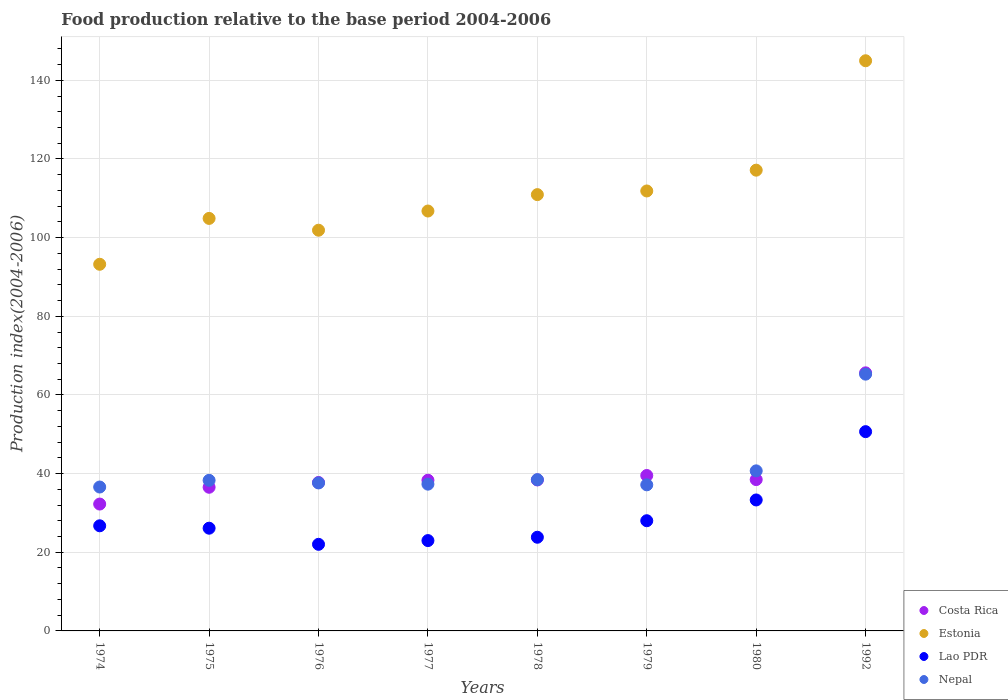What is the food production index in Costa Rica in 1980?
Offer a very short reply. 38.48. Across all years, what is the maximum food production index in Lao PDR?
Offer a terse response. 50.67. Across all years, what is the minimum food production index in Estonia?
Offer a terse response. 93.23. In which year was the food production index in Lao PDR minimum?
Offer a terse response. 1976. What is the total food production index in Nepal in the graph?
Make the answer very short. 331.43. What is the difference between the food production index in Nepal in 1980 and that in 1992?
Ensure brevity in your answer.  -24.59. What is the difference between the food production index in Estonia in 1992 and the food production index in Nepal in 1977?
Your answer should be compact. 107.66. What is the average food production index in Nepal per year?
Your answer should be very brief. 41.43. In the year 1980, what is the difference between the food production index in Costa Rica and food production index in Nepal?
Give a very brief answer. -2.22. What is the ratio of the food production index in Lao PDR in 1976 to that in 1979?
Your answer should be very brief. 0.79. Is the difference between the food production index in Costa Rica in 1976 and 1992 greater than the difference between the food production index in Nepal in 1976 and 1992?
Your response must be concise. No. What is the difference between the highest and the second highest food production index in Estonia?
Offer a very short reply. 27.82. What is the difference between the highest and the lowest food production index in Lao PDR?
Make the answer very short. 28.65. Is it the case that in every year, the sum of the food production index in Nepal and food production index in Lao PDR  is greater than the sum of food production index in Costa Rica and food production index in Estonia?
Your answer should be compact. No. What is the difference between two consecutive major ticks on the Y-axis?
Make the answer very short. 20. Does the graph contain any zero values?
Ensure brevity in your answer.  No. Does the graph contain grids?
Give a very brief answer. Yes. How are the legend labels stacked?
Offer a very short reply. Vertical. What is the title of the graph?
Offer a very short reply. Food production relative to the base period 2004-2006. What is the label or title of the Y-axis?
Offer a very short reply. Production index(2004-2006). What is the Production index(2004-2006) of Costa Rica in 1974?
Provide a succinct answer. 32.26. What is the Production index(2004-2006) of Estonia in 1974?
Your answer should be very brief. 93.23. What is the Production index(2004-2006) of Lao PDR in 1974?
Make the answer very short. 26.73. What is the Production index(2004-2006) of Nepal in 1974?
Your response must be concise. 36.59. What is the Production index(2004-2006) of Costa Rica in 1975?
Your response must be concise. 36.53. What is the Production index(2004-2006) of Estonia in 1975?
Offer a very short reply. 104.89. What is the Production index(2004-2006) of Lao PDR in 1975?
Ensure brevity in your answer.  26.12. What is the Production index(2004-2006) in Nepal in 1975?
Your answer should be compact. 38.29. What is the Production index(2004-2006) in Costa Rica in 1976?
Give a very brief answer. 37.74. What is the Production index(2004-2006) in Estonia in 1976?
Provide a short and direct response. 101.89. What is the Production index(2004-2006) in Lao PDR in 1976?
Your answer should be compact. 22.02. What is the Production index(2004-2006) of Nepal in 1976?
Ensure brevity in your answer.  37.63. What is the Production index(2004-2006) of Costa Rica in 1977?
Ensure brevity in your answer.  38.32. What is the Production index(2004-2006) of Estonia in 1977?
Your answer should be compact. 106.77. What is the Production index(2004-2006) of Lao PDR in 1977?
Make the answer very short. 22.97. What is the Production index(2004-2006) of Nepal in 1977?
Offer a terse response. 37.32. What is the Production index(2004-2006) in Costa Rica in 1978?
Offer a terse response. 38.39. What is the Production index(2004-2006) of Estonia in 1978?
Provide a short and direct response. 110.94. What is the Production index(2004-2006) in Lao PDR in 1978?
Offer a terse response. 23.82. What is the Production index(2004-2006) of Nepal in 1978?
Your response must be concise. 38.46. What is the Production index(2004-2006) in Costa Rica in 1979?
Provide a succinct answer. 39.52. What is the Production index(2004-2006) of Estonia in 1979?
Offer a very short reply. 111.87. What is the Production index(2004-2006) of Lao PDR in 1979?
Make the answer very short. 28.02. What is the Production index(2004-2006) in Nepal in 1979?
Your answer should be very brief. 37.15. What is the Production index(2004-2006) of Costa Rica in 1980?
Make the answer very short. 38.48. What is the Production index(2004-2006) in Estonia in 1980?
Keep it short and to the point. 117.16. What is the Production index(2004-2006) in Lao PDR in 1980?
Give a very brief answer. 33.3. What is the Production index(2004-2006) of Nepal in 1980?
Offer a very short reply. 40.7. What is the Production index(2004-2006) of Costa Rica in 1992?
Provide a succinct answer. 65.62. What is the Production index(2004-2006) in Estonia in 1992?
Give a very brief answer. 144.98. What is the Production index(2004-2006) of Lao PDR in 1992?
Give a very brief answer. 50.67. What is the Production index(2004-2006) of Nepal in 1992?
Provide a succinct answer. 65.29. Across all years, what is the maximum Production index(2004-2006) in Costa Rica?
Provide a short and direct response. 65.62. Across all years, what is the maximum Production index(2004-2006) in Estonia?
Provide a short and direct response. 144.98. Across all years, what is the maximum Production index(2004-2006) of Lao PDR?
Provide a succinct answer. 50.67. Across all years, what is the maximum Production index(2004-2006) of Nepal?
Give a very brief answer. 65.29. Across all years, what is the minimum Production index(2004-2006) in Costa Rica?
Your answer should be very brief. 32.26. Across all years, what is the minimum Production index(2004-2006) in Estonia?
Your answer should be very brief. 93.23. Across all years, what is the minimum Production index(2004-2006) of Lao PDR?
Offer a very short reply. 22.02. Across all years, what is the minimum Production index(2004-2006) of Nepal?
Make the answer very short. 36.59. What is the total Production index(2004-2006) of Costa Rica in the graph?
Your answer should be very brief. 326.86. What is the total Production index(2004-2006) of Estonia in the graph?
Provide a short and direct response. 891.73. What is the total Production index(2004-2006) in Lao PDR in the graph?
Provide a short and direct response. 233.65. What is the total Production index(2004-2006) in Nepal in the graph?
Provide a short and direct response. 331.43. What is the difference between the Production index(2004-2006) in Costa Rica in 1974 and that in 1975?
Offer a very short reply. -4.27. What is the difference between the Production index(2004-2006) in Estonia in 1974 and that in 1975?
Your answer should be very brief. -11.66. What is the difference between the Production index(2004-2006) of Lao PDR in 1974 and that in 1975?
Make the answer very short. 0.61. What is the difference between the Production index(2004-2006) in Nepal in 1974 and that in 1975?
Offer a very short reply. -1.7. What is the difference between the Production index(2004-2006) in Costa Rica in 1974 and that in 1976?
Offer a terse response. -5.48. What is the difference between the Production index(2004-2006) of Estonia in 1974 and that in 1976?
Ensure brevity in your answer.  -8.66. What is the difference between the Production index(2004-2006) in Lao PDR in 1974 and that in 1976?
Offer a terse response. 4.71. What is the difference between the Production index(2004-2006) in Nepal in 1974 and that in 1976?
Give a very brief answer. -1.04. What is the difference between the Production index(2004-2006) in Costa Rica in 1974 and that in 1977?
Your response must be concise. -6.06. What is the difference between the Production index(2004-2006) in Estonia in 1974 and that in 1977?
Offer a very short reply. -13.54. What is the difference between the Production index(2004-2006) in Lao PDR in 1974 and that in 1977?
Your answer should be very brief. 3.76. What is the difference between the Production index(2004-2006) in Nepal in 1974 and that in 1977?
Provide a succinct answer. -0.73. What is the difference between the Production index(2004-2006) of Costa Rica in 1974 and that in 1978?
Your response must be concise. -6.13. What is the difference between the Production index(2004-2006) of Estonia in 1974 and that in 1978?
Your response must be concise. -17.71. What is the difference between the Production index(2004-2006) of Lao PDR in 1974 and that in 1978?
Provide a short and direct response. 2.91. What is the difference between the Production index(2004-2006) in Nepal in 1974 and that in 1978?
Provide a succinct answer. -1.87. What is the difference between the Production index(2004-2006) in Costa Rica in 1974 and that in 1979?
Your answer should be very brief. -7.26. What is the difference between the Production index(2004-2006) of Estonia in 1974 and that in 1979?
Offer a very short reply. -18.64. What is the difference between the Production index(2004-2006) in Lao PDR in 1974 and that in 1979?
Provide a succinct answer. -1.29. What is the difference between the Production index(2004-2006) in Nepal in 1974 and that in 1979?
Make the answer very short. -0.56. What is the difference between the Production index(2004-2006) of Costa Rica in 1974 and that in 1980?
Make the answer very short. -6.22. What is the difference between the Production index(2004-2006) of Estonia in 1974 and that in 1980?
Provide a succinct answer. -23.93. What is the difference between the Production index(2004-2006) in Lao PDR in 1974 and that in 1980?
Your answer should be compact. -6.57. What is the difference between the Production index(2004-2006) in Nepal in 1974 and that in 1980?
Provide a short and direct response. -4.11. What is the difference between the Production index(2004-2006) in Costa Rica in 1974 and that in 1992?
Your response must be concise. -33.36. What is the difference between the Production index(2004-2006) in Estonia in 1974 and that in 1992?
Provide a succinct answer. -51.75. What is the difference between the Production index(2004-2006) of Lao PDR in 1974 and that in 1992?
Provide a succinct answer. -23.94. What is the difference between the Production index(2004-2006) of Nepal in 1974 and that in 1992?
Your answer should be compact. -28.7. What is the difference between the Production index(2004-2006) in Costa Rica in 1975 and that in 1976?
Make the answer very short. -1.21. What is the difference between the Production index(2004-2006) of Nepal in 1975 and that in 1976?
Ensure brevity in your answer.  0.66. What is the difference between the Production index(2004-2006) in Costa Rica in 1975 and that in 1977?
Offer a terse response. -1.79. What is the difference between the Production index(2004-2006) in Estonia in 1975 and that in 1977?
Make the answer very short. -1.88. What is the difference between the Production index(2004-2006) in Lao PDR in 1975 and that in 1977?
Keep it short and to the point. 3.15. What is the difference between the Production index(2004-2006) in Nepal in 1975 and that in 1977?
Offer a terse response. 0.97. What is the difference between the Production index(2004-2006) in Costa Rica in 1975 and that in 1978?
Ensure brevity in your answer.  -1.86. What is the difference between the Production index(2004-2006) of Estonia in 1975 and that in 1978?
Your response must be concise. -6.05. What is the difference between the Production index(2004-2006) of Nepal in 1975 and that in 1978?
Your response must be concise. -0.17. What is the difference between the Production index(2004-2006) in Costa Rica in 1975 and that in 1979?
Offer a very short reply. -2.99. What is the difference between the Production index(2004-2006) of Estonia in 1975 and that in 1979?
Make the answer very short. -6.98. What is the difference between the Production index(2004-2006) of Nepal in 1975 and that in 1979?
Offer a terse response. 1.14. What is the difference between the Production index(2004-2006) of Costa Rica in 1975 and that in 1980?
Offer a terse response. -1.95. What is the difference between the Production index(2004-2006) in Estonia in 1975 and that in 1980?
Your answer should be compact. -12.27. What is the difference between the Production index(2004-2006) of Lao PDR in 1975 and that in 1980?
Your response must be concise. -7.18. What is the difference between the Production index(2004-2006) in Nepal in 1975 and that in 1980?
Keep it short and to the point. -2.41. What is the difference between the Production index(2004-2006) of Costa Rica in 1975 and that in 1992?
Provide a succinct answer. -29.09. What is the difference between the Production index(2004-2006) in Estonia in 1975 and that in 1992?
Provide a succinct answer. -40.09. What is the difference between the Production index(2004-2006) of Lao PDR in 1975 and that in 1992?
Give a very brief answer. -24.55. What is the difference between the Production index(2004-2006) of Nepal in 1975 and that in 1992?
Keep it short and to the point. -27. What is the difference between the Production index(2004-2006) in Costa Rica in 1976 and that in 1977?
Provide a short and direct response. -0.58. What is the difference between the Production index(2004-2006) in Estonia in 1976 and that in 1977?
Offer a very short reply. -4.88. What is the difference between the Production index(2004-2006) in Lao PDR in 1976 and that in 1977?
Give a very brief answer. -0.95. What is the difference between the Production index(2004-2006) in Nepal in 1976 and that in 1977?
Provide a succinct answer. 0.31. What is the difference between the Production index(2004-2006) of Costa Rica in 1976 and that in 1978?
Provide a short and direct response. -0.65. What is the difference between the Production index(2004-2006) of Estonia in 1976 and that in 1978?
Offer a very short reply. -9.05. What is the difference between the Production index(2004-2006) of Nepal in 1976 and that in 1978?
Ensure brevity in your answer.  -0.83. What is the difference between the Production index(2004-2006) of Costa Rica in 1976 and that in 1979?
Provide a short and direct response. -1.78. What is the difference between the Production index(2004-2006) in Estonia in 1976 and that in 1979?
Provide a succinct answer. -9.98. What is the difference between the Production index(2004-2006) of Lao PDR in 1976 and that in 1979?
Give a very brief answer. -6. What is the difference between the Production index(2004-2006) in Nepal in 1976 and that in 1979?
Offer a terse response. 0.48. What is the difference between the Production index(2004-2006) of Costa Rica in 1976 and that in 1980?
Make the answer very short. -0.74. What is the difference between the Production index(2004-2006) in Estonia in 1976 and that in 1980?
Keep it short and to the point. -15.27. What is the difference between the Production index(2004-2006) of Lao PDR in 1976 and that in 1980?
Offer a terse response. -11.28. What is the difference between the Production index(2004-2006) of Nepal in 1976 and that in 1980?
Provide a short and direct response. -3.07. What is the difference between the Production index(2004-2006) in Costa Rica in 1976 and that in 1992?
Keep it short and to the point. -27.88. What is the difference between the Production index(2004-2006) in Estonia in 1976 and that in 1992?
Your answer should be very brief. -43.09. What is the difference between the Production index(2004-2006) of Lao PDR in 1976 and that in 1992?
Keep it short and to the point. -28.65. What is the difference between the Production index(2004-2006) in Nepal in 1976 and that in 1992?
Ensure brevity in your answer.  -27.66. What is the difference between the Production index(2004-2006) of Costa Rica in 1977 and that in 1978?
Give a very brief answer. -0.07. What is the difference between the Production index(2004-2006) of Estonia in 1977 and that in 1978?
Ensure brevity in your answer.  -4.17. What is the difference between the Production index(2004-2006) of Lao PDR in 1977 and that in 1978?
Give a very brief answer. -0.85. What is the difference between the Production index(2004-2006) in Nepal in 1977 and that in 1978?
Offer a very short reply. -1.14. What is the difference between the Production index(2004-2006) in Lao PDR in 1977 and that in 1979?
Your answer should be very brief. -5.05. What is the difference between the Production index(2004-2006) of Nepal in 1977 and that in 1979?
Offer a terse response. 0.17. What is the difference between the Production index(2004-2006) in Costa Rica in 1977 and that in 1980?
Ensure brevity in your answer.  -0.16. What is the difference between the Production index(2004-2006) in Estonia in 1977 and that in 1980?
Offer a very short reply. -10.39. What is the difference between the Production index(2004-2006) in Lao PDR in 1977 and that in 1980?
Your answer should be very brief. -10.33. What is the difference between the Production index(2004-2006) of Nepal in 1977 and that in 1980?
Provide a short and direct response. -3.38. What is the difference between the Production index(2004-2006) in Costa Rica in 1977 and that in 1992?
Offer a terse response. -27.3. What is the difference between the Production index(2004-2006) in Estonia in 1977 and that in 1992?
Ensure brevity in your answer.  -38.21. What is the difference between the Production index(2004-2006) in Lao PDR in 1977 and that in 1992?
Give a very brief answer. -27.7. What is the difference between the Production index(2004-2006) of Nepal in 1977 and that in 1992?
Ensure brevity in your answer.  -27.97. What is the difference between the Production index(2004-2006) of Costa Rica in 1978 and that in 1979?
Keep it short and to the point. -1.13. What is the difference between the Production index(2004-2006) of Estonia in 1978 and that in 1979?
Provide a short and direct response. -0.93. What is the difference between the Production index(2004-2006) of Lao PDR in 1978 and that in 1979?
Your answer should be compact. -4.2. What is the difference between the Production index(2004-2006) in Nepal in 1978 and that in 1979?
Provide a short and direct response. 1.31. What is the difference between the Production index(2004-2006) in Costa Rica in 1978 and that in 1980?
Make the answer very short. -0.09. What is the difference between the Production index(2004-2006) in Estonia in 1978 and that in 1980?
Your answer should be very brief. -6.22. What is the difference between the Production index(2004-2006) of Lao PDR in 1978 and that in 1980?
Offer a very short reply. -9.48. What is the difference between the Production index(2004-2006) in Nepal in 1978 and that in 1980?
Offer a very short reply. -2.24. What is the difference between the Production index(2004-2006) of Costa Rica in 1978 and that in 1992?
Provide a succinct answer. -27.23. What is the difference between the Production index(2004-2006) of Estonia in 1978 and that in 1992?
Give a very brief answer. -34.04. What is the difference between the Production index(2004-2006) in Lao PDR in 1978 and that in 1992?
Provide a succinct answer. -26.85. What is the difference between the Production index(2004-2006) in Nepal in 1978 and that in 1992?
Your answer should be very brief. -26.83. What is the difference between the Production index(2004-2006) in Estonia in 1979 and that in 1980?
Keep it short and to the point. -5.29. What is the difference between the Production index(2004-2006) of Lao PDR in 1979 and that in 1980?
Ensure brevity in your answer.  -5.28. What is the difference between the Production index(2004-2006) in Nepal in 1979 and that in 1980?
Give a very brief answer. -3.55. What is the difference between the Production index(2004-2006) of Costa Rica in 1979 and that in 1992?
Offer a very short reply. -26.1. What is the difference between the Production index(2004-2006) in Estonia in 1979 and that in 1992?
Offer a very short reply. -33.11. What is the difference between the Production index(2004-2006) of Lao PDR in 1979 and that in 1992?
Offer a terse response. -22.65. What is the difference between the Production index(2004-2006) of Nepal in 1979 and that in 1992?
Your answer should be compact. -28.14. What is the difference between the Production index(2004-2006) of Costa Rica in 1980 and that in 1992?
Your answer should be very brief. -27.14. What is the difference between the Production index(2004-2006) of Estonia in 1980 and that in 1992?
Your answer should be compact. -27.82. What is the difference between the Production index(2004-2006) in Lao PDR in 1980 and that in 1992?
Your response must be concise. -17.37. What is the difference between the Production index(2004-2006) in Nepal in 1980 and that in 1992?
Ensure brevity in your answer.  -24.59. What is the difference between the Production index(2004-2006) in Costa Rica in 1974 and the Production index(2004-2006) in Estonia in 1975?
Ensure brevity in your answer.  -72.63. What is the difference between the Production index(2004-2006) in Costa Rica in 1974 and the Production index(2004-2006) in Lao PDR in 1975?
Your response must be concise. 6.14. What is the difference between the Production index(2004-2006) of Costa Rica in 1974 and the Production index(2004-2006) of Nepal in 1975?
Your answer should be very brief. -6.03. What is the difference between the Production index(2004-2006) of Estonia in 1974 and the Production index(2004-2006) of Lao PDR in 1975?
Ensure brevity in your answer.  67.11. What is the difference between the Production index(2004-2006) of Estonia in 1974 and the Production index(2004-2006) of Nepal in 1975?
Your answer should be very brief. 54.94. What is the difference between the Production index(2004-2006) of Lao PDR in 1974 and the Production index(2004-2006) of Nepal in 1975?
Give a very brief answer. -11.56. What is the difference between the Production index(2004-2006) of Costa Rica in 1974 and the Production index(2004-2006) of Estonia in 1976?
Make the answer very short. -69.63. What is the difference between the Production index(2004-2006) in Costa Rica in 1974 and the Production index(2004-2006) in Lao PDR in 1976?
Provide a short and direct response. 10.24. What is the difference between the Production index(2004-2006) in Costa Rica in 1974 and the Production index(2004-2006) in Nepal in 1976?
Give a very brief answer. -5.37. What is the difference between the Production index(2004-2006) of Estonia in 1974 and the Production index(2004-2006) of Lao PDR in 1976?
Offer a terse response. 71.21. What is the difference between the Production index(2004-2006) in Estonia in 1974 and the Production index(2004-2006) in Nepal in 1976?
Your response must be concise. 55.6. What is the difference between the Production index(2004-2006) in Lao PDR in 1974 and the Production index(2004-2006) in Nepal in 1976?
Give a very brief answer. -10.9. What is the difference between the Production index(2004-2006) in Costa Rica in 1974 and the Production index(2004-2006) in Estonia in 1977?
Provide a succinct answer. -74.51. What is the difference between the Production index(2004-2006) of Costa Rica in 1974 and the Production index(2004-2006) of Lao PDR in 1977?
Ensure brevity in your answer.  9.29. What is the difference between the Production index(2004-2006) of Costa Rica in 1974 and the Production index(2004-2006) of Nepal in 1977?
Offer a terse response. -5.06. What is the difference between the Production index(2004-2006) of Estonia in 1974 and the Production index(2004-2006) of Lao PDR in 1977?
Your response must be concise. 70.26. What is the difference between the Production index(2004-2006) of Estonia in 1974 and the Production index(2004-2006) of Nepal in 1977?
Offer a very short reply. 55.91. What is the difference between the Production index(2004-2006) of Lao PDR in 1974 and the Production index(2004-2006) of Nepal in 1977?
Offer a terse response. -10.59. What is the difference between the Production index(2004-2006) in Costa Rica in 1974 and the Production index(2004-2006) in Estonia in 1978?
Ensure brevity in your answer.  -78.68. What is the difference between the Production index(2004-2006) of Costa Rica in 1974 and the Production index(2004-2006) of Lao PDR in 1978?
Offer a very short reply. 8.44. What is the difference between the Production index(2004-2006) in Costa Rica in 1974 and the Production index(2004-2006) in Nepal in 1978?
Your answer should be compact. -6.2. What is the difference between the Production index(2004-2006) in Estonia in 1974 and the Production index(2004-2006) in Lao PDR in 1978?
Provide a succinct answer. 69.41. What is the difference between the Production index(2004-2006) in Estonia in 1974 and the Production index(2004-2006) in Nepal in 1978?
Provide a short and direct response. 54.77. What is the difference between the Production index(2004-2006) of Lao PDR in 1974 and the Production index(2004-2006) of Nepal in 1978?
Offer a terse response. -11.73. What is the difference between the Production index(2004-2006) in Costa Rica in 1974 and the Production index(2004-2006) in Estonia in 1979?
Offer a terse response. -79.61. What is the difference between the Production index(2004-2006) in Costa Rica in 1974 and the Production index(2004-2006) in Lao PDR in 1979?
Your response must be concise. 4.24. What is the difference between the Production index(2004-2006) of Costa Rica in 1974 and the Production index(2004-2006) of Nepal in 1979?
Ensure brevity in your answer.  -4.89. What is the difference between the Production index(2004-2006) in Estonia in 1974 and the Production index(2004-2006) in Lao PDR in 1979?
Your response must be concise. 65.21. What is the difference between the Production index(2004-2006) in Estonia in 1974 and the Production index(2004-2006) in Nepal in 1979?
Ensure brevity in your answer.  56.08. What is the difference between the Production index(2004-2006) of Lao PDR in 1974 and the Production index(2004-2006) of Nepal in 1979?
Ensure brevity in your answer.  -10.42. What is the difference between the Production index(2004-2006) of Costa Rica in 1974 and the Production index(2004-2006) of Estonia in 1980?
Make the answer very short. -84.9. What is the difference between the Production index(2004-2006) of Costa Rica in 1974 and the Production index(2004-2006) of Lao PDR in 1980?
Offer a very short reply. -1.04. What is the difference between the Production index(2004-2006) in Costa Rica in 1974 and the Production index(2004-2006) in Nepal in 1980?
Provide a succinct answer. -8.44. What is the difference between the Production index(2004-2006) in Estonia in 1974 and the Production index(2004-2006) in Lao PDR in 1980?
Your answer should be compact. 59.93. What is the difference between the Production index(2004-2006) of Estonia in 1974 and the Production index(2004-2006) of Nepal in 1980?
Provide a short and direct response. 52.53. What is the difference between the Production index(2004-2006) in Lao PDR in 1974 and the Production index(2004-2006) in Nepal in 1980?
Provide a succinct answer. -13.97. What is the difference between the Production index(2004-2006) of Costa Rica in 1974 and the Production index(2004-2006) of Estonia in 1992?
Provide a short and direct response. -112.72. What is the difference between the Production index(2004-2006) in Costa Rica in 1974 and the Production index(2004-2006) in Lao PDR in 1992?
Keep it short and to the point. -18.41. What is the difference between the Production index(2004-2006) in Costa Rica in 1974 and the Production index(2004-2006) in Nepal in 1992?
Your answer should be compact. -33.03. What is the difference between the Production index(2004-2006) in Estonia in 1974 and the Production index(2004-2006) in Lao PDR in 1992?
Ensure brevity in your answer.  42.56. What is the difference between the Production index(2004-2006) of Estonia in 1974 and the Production index(2004-2006) of Nepal in 1992?
Offer a very short reply. 27.94. What is the difference between the Production index(2004-2006) of Lao PDR in 1974 and the Production index(2004-2006) of Nepal in 1992?
Ensure brevity in your answer.  -38.56. What is the difference between the Production index(2004-2006) in Costa Rica in 1975 and the Production index(2004-2006) in Estonia in 1976?
Your answer should be very brief. -65.36. What is the difference between the Production index(2004-2006) of Costa Rica in 1975 and the Production index(2004-2006) of Lao PDR in 1976?
Your answer should be very brief. 14.51. What is the difference between the Production index(2004-2006) in Estonia in 1975 and the Production index(2004-2006) in Lao PDR in 1976?
Offer a very short reply. 82.87. What is the difference between the Production index(2004-2006) in Estonia in 1975 and the Production index(2004-2006) in Nepal in 1976?
Provide a short and direct response. 67.26. What is the difference between the Production index(2004-2006) of Lao PDR in 1975 and the Production index(2004-2006) of Nepal in 1976?
Keep it short and to the point. -11.51. What is the difference between the Production index(2004-2006) of Costa Rica in 1975 and the Production index(2004-2006) of Estonia in 1977?
Give a very brief answer. -70.24. What is the difference between the Production index(2004-2006) in Costa Rica in 1975 and the Production index(2004-2006) in Lao PDR in 1977?
Give a very brief answer. 13.56. What is the difference between the Production index(2004-2006) of Costa Rica in 1975 and the Production index(2004-2006) of Nepal in 1977?
Offer a very short reply. -0.79. What is the difference between the Production index(2004-2006) of Estonia in 1975 and the Production index(2004-2006) of Lao PDR in 1977?
Your response must be concise. 81.92. What is the difference between the Production index(2004-2006) in Estonia in 1975 and the Production index(2004-2006) in Nepal in 1977?
Give a very brief answer. 67.57. What is the difference between the Production index(2004-2006) in Costa Rica in 1975 and the Production index(2004-2006) in Estonia in 1978?
Provide a succinct answer. -74.41. What is the difference between the Production index(2004-2006) in Costa Rica in 1975 and the Production index(2004-2006) in Lao PDR in 1978?
Keep it short and to the point. 12.71. What is the difference between the Production index(2004-2006) of Costa Rica in 1975 and the Production index(2004-2006) of Nepal in 1978?
Ensure brevity in your answer.  -1.93. What is the difference between the Production index(2004-2006) of Estonia in 1975 and the Production index(2004-2006) of Lao PDR in 1978?
Provide a short and direct response. 81.07. What is the difference between the Production index(2004-2006) in Estonia in 1975 and the Production index(2004-2006) in Nepal in 1978?
Provide a succinct answer. 66.43. What is the difference between the Production index(2004-2006) of Lao PDR in 1975 and the Production index(2004-2006) of Nepal in 1978?
Keep it short and to the point. -12.34. What is the difference between the Production index(2004-2006) in Costa Rica in 1975 and the Production index(2004-2006) in Estonia in 1979?
Ensure brevity in your answer.  -75.34. What is the difference between the Production index(2004-2006) in Costa Rica in 1975 and the Production index(2004-2006) in Lao PDR in 1979?
Provide a succinct answer. 8.51. What is the difference between the Production index(2004-2006) in Costa Rica in 1975 and the Production index(2004-2006) in Nepal in 1979?
Provide a succinct answer. -0.62. What is the difference between the Production index(2004-2006) in Estonia in 1975 and the Production index(2004-2006) in Lao PDR in 1979?
Offer a terse response. 76.87. What is the difference between the Production index(2004-2006) in Estonia in 1975 and the Production index(2004-2006) in Nepal in 1979?
Give a very brief answer. 67.74. What is the difference between the Production index(2004-2006) in Lao PDR in 1975 and the Production index(2004-2006) in Nepal in 1979?
Your answer should be compact. -11.03. What is the difference between the Production index(2004-2006) of Costa Rica in 1975 and the Production index(2004-2006) of Estonia in 1980?
Your answer should be compact. -80.63. What is the difference between the Production index(2004-2006) in Costa Rica in 1975 and the Production index(2004-2006) in Lao PDR in 1980?
Make the answer very short. 3.23. What is the difference between the Production index(2004-2006) of Costa Rica in 1975 and the Production index(2004-2006) of Nepal in 1980?
Offer a terse response. -4.17. What is the difference between the Production index(2004-2006) of Estonia in 1975 and the Production index(2004-2006) of Lao PDR in 1980?
Keep it short and to the point. 71.59. What is the difference between the Production index(2004-2006) in Estonia in 1975 and the Production index(2004-2006) in Nepal in 1980?
Keep it short and to the point. 64.19. What is the difference between the Production index(2004-2006) in Lao PDR in 1975 and the Production index(2004-2006) in Nepal in 1980?
Offer a terse response. -14.58. What is the difference between the Production index(2004-2006) in Costa Rica in 1975 and the Production index(2004-2006) in Estonia in 1992?
Offer a terse response. -108.45. What is the difference between the Production index(2004-2006) in Costa Rica in 1975 and the Production index(2004-2006) in Lao PDR in 1992?
Make the answer very short. -14.14. What is the difference between the Production index(2004-2006) of Costa Rica in 1975 and the Production index(2004-2006) of Nepal in 1992?
Provide a short and direct response. -28.76. What is the difference between the Production index(2004-2006) in Estonia in 1975 and the Production index(2004-2006) in Lao PDR in 1992?
Give a very brief answer. 54.22. What is the difference between the Production index(2004-2006) in Estonia in 1975 and the Production index(2004-2006) in Nepal in 1992?
Your answer should be very brief. 39.6. What is the difference between the Production index(2004-2006) in Lao PDR in 1975 and the Production index(2004-2006) in Nepal in 1992?
Your response must be concise. -39.17. What is the difference between the Production index(2004-2006) in Costa Rica in 1976 and the Production index(2004-2006) in Estonia in 1977?
Your response must be concise. -69.03. What is the difference between the Production index(2004-2006) of Costa Rica in 1976 and the Production index(2004-2006) of Lao PDR in 1977?
Make the answer very short. 14.77. What is the difference between the Production index(2004-2006) in Costa Rica in 1976 and the Production index(2004-2006) in Nepal in 1977?
Your response must be concise. 0.42. What is the difference between the Production index(2004-2006) in Estonia in 1976 and the Production index(2004-2006) in Lao PDR in 1977?
Give a very brief answer. 78.92. What is the difference between the Production index(2004-2006) of Estonia in 1976 and the Production index(2004-2006) of Nepal in 1977?
Ensure brevity in your answer.  64.57. What is the difference between the Production index(2004-2006) of Lao PDR in 1976 and the Production index(2004-2006) of Nepal in 1977?
Ensure brevity in your answer.  -15.3. What is the difference between the Production index(2004-2006) of Costa Rica in 1976 and the Production index(2004-2006) of Estonia in 1978?
Keep it short and to the point. -73.2. What is the difference between the Production index(2004-2006) of Costa Rica in 1976 and the Production index(2004-2006) of Lao PDR in 1978?
Your answer should be very brief. 13.92. What is the difference between the Production index(2004-2006) in Costa Rica in 1976 and the Production index(2004-2006) in Nepal in 1978?
Give a very brief answer. -0.72. What is the difference between the Production index(2004-2006) in Estonia in 1976 and the Production index(2004-2006) in Lao PDR in 1978?
Provide a succinct answer. 78.07. What is the difference between the Production index(2004-2006) of Estonia in 1976 and the Production index(2004-2006) of Nepal in 1978?
Give a very brief answer. 63.43. What is the difference between the Production index(2004-2006) in Lao PDR in 1976 and the Production index(2004-2006) in Nepal in 1978?
Keep it short and to the point. -16.44. What is the difference between the Production index(2004-2006) in Costa Rica in 1976 and the Production index(2004-2006) in Estonia in 1979?
Provide a short and direct response. -74.13. What is the difference between the Production index(2004-2006) in Costa Rica in 1976 and the Production index(2004-2006) in Lao PDR in 1979?
Ensure brevity in your answer.  9.72. What is the difference between the Production index(2004-2006) of Costa Rica in 1976 and the Production index(2004-2006) of Nepal in 1979?
Keep it short and to the point. 0.59. What is the difference between the Production index(2004-2006) of Estonia in 1976 and the Production index(2004-2006) of Lao PDR in 1979?
Provide a short and direct response. 73.87. What is the difference between the Production index(2004-2006) of Estonia in 1976 and the Production index(2004-2006) of Nepal in 1979?
Keep it short and to the point. 64.74. What is the difference between the Production index(2004-2006) in Lao PDR in 1976 and the Production index(2004-2006) in Nepal in 1979?
Your answer should be compact. -15.13. What is the difference between the Production index(2004-2006) of Costa Rica in 1976 and the Production index(2004-2006) of Estonia in 1980?
Offer a very short reply. -79.42. What is the difference between the Production index(2004-2006) of Costa Rica in 1976 and the Production index(2004-2006) of Lao PDR in 1980?
Provide a succinct answer. 4.44. What is the difference between the Production index(2004-2006) of Costa Rica in 1976 and the Production index(2004-2006) of Nepal in 1980?
Provide a short and direct response. -2.96. What is the difference between the Production index(2004-2006) in Estonia in 1976 and the Production index(2004-2006) in Lao PDR in 1980?
Offer a terse response. 68.59. What is the difference between the Production index(2004-2006) in Estonia in 1976 and the Production index(2004-2006) in Nepal in 1980?
Give a very brief answer. 61.19. What is the difference between the Production index(2004-2006) in Lao PDR in 1976 and the Production index(2004-2006) in Nepal in 1980?
Keep it short and to the point. -18.68. What is the difference between the Production index(2004-2006) in Costa Rica in 1976 and the Production index(2004-2006) in Estonia in 1992?
Give a very brief answer. -107.24. What is the difference between the Production index(2004-2006) of Costa Rica in 1976 and the Production index(2004-2006) of Lao PDR in 1992?
Provide a short and direct response. -12.93. What is the difference between the Production index(2004-2006) in Costa Rica in 1976 and the Production index(2004-2006) in Nepal in 1992?
Make the answer very short. -27.55. What is the difference between the Production index(2004-2006) in Estonia in 1976 and the Production index(2004-2006) in Lao PDR in 1992?
Your answer should be very brief. 51.22. What is the difference between the Production index(2004-2006) of Estonia in 1976 and the Production index(2004-2006) of Nepal in 1992?
Provide a short and direct response. 36.6. What is the difference between the Production index(2004-2006) of Lao PDR in 1976 and the Production index(2004-2006) of Nepal in 1992?
Offer a terse response. -43.27. What is the difference between the Production index(2004-2006) of Costa Rica in 1977 and the Production index(2004-2006) of Estonia in 1978?
Your answer should be compact. -72.62. What is the difference between the Production index(2004-2006) in Costa Rica in 1977 and the Production index(2004-2006) in Lao PDR in 1978?
Give a very brief answer. 14.5. What is the difference between the Production index(2004-2006) of Costa Rica in 1977 and the Production index(2004-2006) of Nepal in 1978?
Offer a very short reply. -0.14. What is the difference between the Production index(2004-2006) in Estonia in 1977 and the Production index(2004-2006) in Lao PDR in 1978?
Provide a succinct answer. 82.95. What is the difference between the Production index(2004-2006) in Estonia in 1977 and the Production index(2004-2006) in Nepal in 1978?
Provide a short and direct response. 68.31. What is the difference between the Production index(2004-2006) in Lao PDR in 1977 and the Production index(2004-2006) in Nepal in 1978?
Provide a succinct answer. -15.49. What is the difference between the Production index(2004-2006) in Costa Rica in 1977 and the Production index(2004-2006) in Estonia in 1979?
Offer a very short reply. -73.55. What is the difference between the Production index(2004-2006) in Costa Rica in 1977 and the Production index(2004-2006) in Lao PDR in 1979?
Provide a succinct answer. 10.3. What is the difference between the Production index(2004-2006) of Costa Rica in 1977 and the Production index(2004-2006) of Nepal in 1979?
Provide a short and direct response. 1.17. What is the difference between the Production index(2004-2006) in Estonia in 1977 and the Production index(2004-2006) in Lao PDR in 1979?
Your answer should be compact. 78.75. What is the difference between the Production index(2004-2006) of Estonia in 1977 and the Production index(2004-2006) of Nepal in 1979?
Your answer should be compact. 69.62. What is the difference between the Production index(2004-2006) of Lao PDR in 1977 and the Production index(2004-2006) of Nepal in 1979?
Provide a short and direct response. -14.18. What is the difference between the Production index(2004-2006) in Costa Rica in 1977 and the Production index(2004-2006) in Estonia in 1980?
Provide a succinct answer. -78.84. What is the difference between the Production index(2004-2006) of Costa Rica in 1977 and the Production index(2004-2006) of Lao PDR in 1980?
Your answer should be very brief. 5.02. What is the difference between the Production index(2004-2006) of Costa Rica in 1977 and the Production index(2004-2006) of Nepal in 1980?
Offer a very short reply. -2.38. What is the difference between the Production index(2004-2006) in Estonia in 1977 and the Production index(2004-2006) in Lao PDR in 1980?
Your answer should be compact. 73.47. What is the difference between the Production index(2004-2006) in Estonia in 1977 and the Production index(2004-2006) in Nepal in 1980?
Your answer should be very brief. 66.07. What is the difference between the Production index(2004-2006) in Lao PDR in 1977 and the Production index(2004-2006) in Nepal in 1980?
Your answer should be very brief. -17.73. What is the difference between the Production index(2004-2006) in Costa Rica in 1977 and the Production index(2004-2006) in Estonia in 1992?
Make the answer very short. -106.66. What is the difference between the Production index(2004-2006) of Costa Rica in 1977 and the Production index(2004-2006) of Lao PDR in 1992?
Provide a short and direct response. -12.35. What is the difference between the Production index(2004-2006) in Costa Rica in 1977 and the Production index(2004-2006) in Nepal in 1992?
Make the answer very short. -26.97. What is the difference between the Production index(2004-2006) in Estonia in 1977 and the Production index(2004-2006) in Lao PDR in 1992?
Offer a terse response. 56.1. What is the difference between the Production index(2004-2006) of Estonia in 1977 and the Production index(2004-2006) of Nepal in 1992?
Give a very brief answer. 41.48. What is the difference between the Production index(2004-2006) in Lao PDR in 1977 and the Production index(2004-2006) in Nepal in 1992?
Provide a short and direct response. -42.32. What is the difference between the Production index(2004-2006) of Costa Rica in 1978 and the Production index(2004-2006) of Estonia in 1979?
Offer a terse response. -73.48. What is the difference between the Production index(2004-2006) of Costa Rica in 1978 and the Production index(2004-2006) of Lao PDR in 1979?
Keep it short and to the point. 10.37. What is the difference between the Production index(2004-2006) of Costa Rica in 1978 and the Production index(2004-2006) of Nepal in 1979?
Offer a terse response. 1.24. What is the difference between the Production index(2004-2006) in Estonia in 1978 and the Production index(2004-2006) in Lao PDR in 1979?
Your response must be concise. 82.92. What is the difference between the Production index(2004-2006) of Estonia in 1978 and the Production index(2004-2006) of Nepal in 1979?
Provide a succinct answer. 73.79. What is the difference between the Production index(2004-2006) of Lao PDR in 1978 and the Production index(2004-2006) of Nepal in 1979?
Keep it short and to the point. -13.33. What is the difference between the Production index(2004-2006) in Costa Rica in 1978 and the Production index(2004-2006) in Estonia in 1980?
Provide a short and direct response. -78.77. What is the difference between the Production index(2004-2006) in Costa Rica in 1978 and the Production index(2004-2006) in Lao PDR in 1980?
Provide a succinct answer. 5.09. What is the difference between the Production index(2004-2006) of Costa Rica in 1978 and the Production index(2004-2006) of Nepal in 1980?
Provide a short and direct response. -2.31. What is the difference between the Production index(2004-2006) of Estonia in 1978 and the Production index(2004-2006) of Lao PDR in 1980?
Give a very brief answer. 77.64. What is the difference between the Production index(2004-2006) in Estonia in 1978 and the Production index(2004-2006) in Nepal in 1980?
Your answer should be compact. 70.24. What is the difference between the Production index(2004-2006) in Lao PDR in 1978 and the Production index(2004-2006) in Nepal in 1980?
Your answer should be very brief. -16.88. What is the difference between the Production index(2004-2006) of Costa Rica in 1978 and the Production index(2004-2006) of Estonia in 1992?
Offer a terse response. -106.59. What is the difference between the Production index(2004-2006) in Costa Rica in 1978 and the Production index(2004-2006) in Lao PDR in 1992?
Your answer should be very brief. -12.28. What is the difference between the Production index(2004-2006) of Costa Rica in 1978 and the Production index(2004-2006) of Nepal in 1992?
Your answer should be compact. -26.9. What is the difference between the Production index(2004-2006) in Estonia in 1978 and the Production index(2004-2006) in Lao PDR in 1992?
Provide a short and direct response. 60.27. What is the difference between the Production index(2004-2006) in Estonia in 1978 and the Production index(2004-2006) in Nepal in 1992?
Your answer should be very brief. 45.65. What is the difference between the Production index(2004-2006) in Lao PDR in 1978 and the Production index(2004-2006) in Nepal in 1992?
Your answer should be compact. -41.47. What is the difference between the Production index(2004-2006) of Costa Rica in 1979 and the Production index(2004-2006) of Estonia in 1980?
Your answer should be compact. -77.64. What is the difference between the Production index(2004-2006) in Costa Rica in 1979 and the Production index(2004-2006) in Lao PDR in 1980?
Make the answer very short. 6.22. What is the difference between the Production index(2004-2006) of Costa Rica in 1979 and the Production index(2004-2006) of Nepal in 1980?
Offer a terse response. -1.18. What is the difference between the Production index(2004-2006) of Estonia in 1979 and the Production index(2004-2006) of Lao PDR in 1980?
Give a very brief answer. 78.57. What is the difference between the Production index(2004-2006) in Estonia in 1979 and the Production index(2004-2006) in Nepal in 1980?
Your answer should be very brief. 71.17. What is the difference between the Production index(2004-2006) of Lao PDR in 1979 and the Production index(2004-2006) of Nepal in 1980?
Ensure brevity in your answer.  -12.68. What is the difference between the Production index(2004-2006) in Costa Rica in 1979 and the Production index(2004-2006) in Estonia in 1992?
Your answer should be compact. -105.46. What is the difference between the Production index(2004-2006) in Costa Rica in 1979 and the Production index(2004-2006) in Lao PDR in 1992?
Your answer should be very brief. -11.15. What is the difference between the Production index(2004-2006) in Costa Rica in 1979 and the Production index(2004-2006) in Nepal in 1992?
Your answer should be very brief. -25.77. What is the difference between the Production index(2004-2006) in Estonia in 1979 and the Production index(2004-2006) in Lao PDR in 1992?
Your answer should be compact. 61.2. What is the difference between the Production index(2004-2006) in Estonia in 1979 and the Production index(2004-2006) in Nepal in 1992?
Give a very brief answer. 46.58. What is the difference between the Production index(2004-2006) in Lao PDR in 1979 and the Production index(2004-2006) in Nepal in 1992?
Your response must be concise. -37.27. What is the difference between the Production index(2004-2006) of Costa Rica in 1980 and the Production index(2004-2006) of Estonia in 1992?
Keep it short and to the point. -106.5. What is the difference between the Production index(2004-2006) of Costa Rica in 1980 and the Production index(2004-2006) of Lao PDR in 1992?
Your response must be concise. -12.19. What is the difference between the Production index(2004-2006) of Costa Rica in 1980 and the Production index(2004-2006) of Nepal in 1992?
Give a very brief answer. -26.81. What is the difference between the Production index(2004-2006) in Estonia in 1980 and the Production index(2004-2006) in Lao PDR in 1992?
Make the answer very short. 66.49. What is the difference between the Production index(2004-2006) of Estonia in 1980 and the Production index(2004-2006) of Nepal in 1992?
Your answer should be very brief. 51.87. What is the difference between the Production index(2004-2006) of Lao PDR in 1980 and the Production index(2004-2006) of Nepal in 1992?
Make the answer very short. -31.99. What is the average Production index(2004-2006) of Costa Rica per year?
Your answer should be very brief. 40.86. What is the average Production index(2004-2006) in Estonia per year?
Your response must be concise. 111.47. What is the average Production index(2004-2006) in Lao PDR per year?
Provide a short and direct response. 29.21. What is the average Production index(2004-2006) in Nepal per year?
Make the answer very short. 41.43. In the year 1974, what is the difference between the Production index(2004-2006) in Costa Rica and Production index(2004-2006) in Estonia?
Provide a short and direct response. -60.97. In the year 1974, what is the difference between the Production index(2004-2006) in Costa Rica and Production index(2004-2006) in Lao PDR?
Your answer should be very brief. 5.53. In the year 1974, what is the difference between the Production index(2004-2006) of Costa Rica and Production index(2004-2006) of Nepal?
Ensure brevity in your answer.  -4.33. In the year 1974, what is the difference between the Production index(2004-2006) in Estonia and Production index(2004-2006) in Lao PDR?
Your answer should be compact. 66.5. In the year 1974, what is the difference between the Production index(2004-2006) of Estonia and Production index(2004-2006) of Nepal?
Offer a very short reply. 56.64. In the year 1974, what is the difference between the Production index(2004-2006) of Lao PDR and Production index(2004-2006) of Nepal?
Keep it short and to the point. -9.86. In the year 1975, what is the difference between the Production index(2004-2006) in Costa Rica and Production index(2004-2006) in Estonia?
Offer a very short reply. -68.36. In the year 1975, what is the difference between the Production index(2004-2006) of Costa Rica and Production index(2004-2006) of Lao PDR?
Provide a succinct answer. 10.41. In the year 1975, what is the difference between the Production index(2004-2006) in Costa Rica and Production index(2004-2006) in Nepal?
Provide a succinct answer. -1.76. In the year 1975, what is the difference between the Production index(2004-2006) in Estonia and Production index(2004-2006) in Lao PDR?
Offer a terse response. 78.77. In the year 1975, what is the difference between the Production index(2004-2006) in Estonia and Production index(2004-2006) in Nepal?
Your answer should be very brief. 66.6. In the year 1975, what is the difference between the Production index(2004-2006) in Lao PDR and Production index(2004-2006) in Nepal?
Make the answer very short. -12.17. In the year 1976, what is the difference between the Production index(2004-2006) in Costa Rica and Production index(2004-2006) in Estonia?
Ensure brevity in your answer.  -64.15. In the year 1976, what is the difference between the Production index(2004-2006) of Costa Rica and Production index(2004-2006) of Lao PDR?
Make the answer very short. 15.72. In the year 1976, what is the difference between the Production index(2004-2006) of Costa Rica and Production index(2004-2006) of Nepal?
Make the answer very short. 0.11. In the year 1976, what is the difference between the Production index(2004-2006) of Estonia and Production index(2004-2006) of Lao PDR?
Make the answer very short. 79.87. In the year 1976, what is the difference between the Production index(2004-2006) in Estonia and Production index(2004-2006) in Nepal?
Your answer should be compact. 64.26. In the year 1976, what is the difference between the Production index(2004-2006) in Lao PDR and Production index(2004-2006) in Nepal?
Provide a short and direct response. -15.61. In the year 1977, what is the difference between the Production index(2004-2006) of Costa Rica and Production index(2004-2006) of Estonia?
Provide a short and direct response. -68.45. In the year 1977, what is the difference between the Production index(2004-2006) in Costa Rica and Production index(2004-2006) in Lao PDR?
Keep it short and to the point. 15.35. In the year 1977, what is the difference between the Production index(2004-2006) of Costa Rica and Production index(2004-2006) of Nepal?
Make the answer very short. 1. In the year 1977, what is the difference between the Production index(2004-2006) of Estonia and Production index(2004-2006) of Lao PDR?
Make the answer very short. 83.8. In the year 1977, what is the difference between the Production index(2004-2006) of Estonia and Production index(2004-2006) of Nepal?
Ensure brevity in your answer.  69.45. In the year 1977, what is the difference between the Production index(2004-2006) of Lao PDR and Production index(2004-2006) of Nepal?
Make the answer very short. -14.35. In the year 1978, what is the difference between the Production index(2004-2006) in Costa Rica and Production index(2004-2006) in Estonia?
Offer a terse response. -72.55. In the year 1978, what is the difference between the Production index(2004-2006) of Costa Rica and Production index(2004-2006) of Lao PDR?
Ensure brevity in your answer.  14.57. In the year 1978, what is the difference between the Production index(2004-2006) of Costa Rica and Production index(2004-2006) of Nepal?
Ensure brevity in your answer.  -0.07. In the year 1978, what is the difference between the Production index(2004-2006) of Estonia and Production index(2004-2006) of Lao PDR?
Make the answer very short. 87.12. In the year 1978, what is the difference between the Production index(2004-2006) in Estonia and Production index(2004-2006) in Nepal?
Make the answer very short. 72.48. In the year 1978, what is the difference between the Production index(2004-2006) in Lao PDR and Production index(2004-2006) in Nepal?
Give a very brief answer. -14.64. In the year 1979, what is the difference between the Production index(2004-2006) in Costa Rica and Production index(2004-2006) in Estonia?
Ensure brevity in your answer.  -72.35. In the year 1979, what is the difference between the Production index(2004-2006) of Costa Rica and Production index(2004-2006) of Nepal?
Offer a terse response. 2.37. In the year 1979, what is the difference between the Production index(2004-2006) in Estonia and Production index(2004-2006) in Lao PDR?
Offer a terse response. 83.85. In the year 1979, what is the difference between the Production index(2004-2006) in Estonia and Production index(2004-2006) in Nepal?
Give a very brief answer. 74.72. In the year 1979, what is the difference between the Production index(2004-2006) in Lao PDR and Production index(2004-2006) in Nepal?
Offer a very short reply. -9.13. In the year 1980, what is the difference between the Production index(2004-2006) in Costa Rica and Production index(2004-2006) in Estonia?
Offer a terse response. -78.68. In the year 1980, what is the difference between the Production index(2004-2006) of Costa Rica and Production index(2004-2006) of Lao PDR?
Your response must be concise. 5.18. In the year 1980, what is the difference between the Production index(2004-2006) in Costa Rica and Production index(2004-2006) in Nepal?
Offer a terse response. -2.22. In the year 1980, what is the difference between the Production index(2004-2006) in Estonia and Production index(2004-2006) in Lao PDR?
Your response must be concise. 83.86. In the year 1980, what is the difference between the Production index(2004-2006) of Estonia and Production index(2004-2006) of Nepal?
Make the answer very short. 76.46. In the year 1980, what is the difference between the Production index(2004-2006) of Lao PDR and Production index(2004-2006) of Nepal?
Offer a terse response. -7.4. In the year 1992, what is the difference between the Production index(2004-2006) in Costa Rica and Production index(2004-2006) in Estonia?
Offer a very short reply. -79.36. In the year 1992, what is the difference between the Production index(2004-2006) of Costa Rica and Production index(2004-2006) of Lao PDR?
Offer a very short reply. 14.95. In the year 1992, what is the difference between the Production index(2004-2006) in Costa Rica and Production index(2004-2006) in Nepal?
Keep it short and to the point. 0.33. In the year 1992, what is the difference between the Production index(2004-2006) in Estonia and Production index(2004-2006) in Lao PDR?
Make the answer very short. 94.31. In the year 1992, what is the difference between the Production index(2004-2006) in Estonia and Production index(2004-2006) in Nepal?
Ensure brevity in your answer.  79.69. In the year 1992, what is the difference between the Production index(2004-2006) in Lao PDR and Production index(2004-2006) in Nepal?
Make the answer very short. -14.62. What is the ratio of the Production index(2004-2006) of Costa Rica in 1974 to that in 1975?
Keep it short and to the point. 0.88. What is the ratio of the Production index(2004-2006) in Estonia in 1974 to that in 1975?
Your answer should be compact. 0.89. What is the ratio of the Production index(2004-2006) of Lao PDR in 1974 to that in 1975?
Offer a very short reply. 1.02. What is the ratio of the Production index(2004-2006) of Nepal in 1974 to that in 1975?
Your answer should be compact. 0.96. What is the ratio of the Production index(2004-2006) of Costa Rica in 1974 to that in 1976?
Offer a very short reply. 0.85. What is the ratio of the Production index(2004-2006) of Estonia in 1974 to that in 1976?
Give a very brief answer. 0.92. What is the ratio of the Production index(2004-2006) in Lao PDR in 1974 to that in 1976?
Offer a terse response. 1.21. What is the ratio of the Production index(2004-2006) in Nepal in 1974 to that in 1976?
Provide a short and direct response. 0.97. What is the ratio of the Production index(2004-2006) of Costa Rica in 1974 to that in 1977?
Provide a succinct answer. 0.84. What is the ratio of the Production index(2004-2006) of Estonia in 1974 to that in 1977?
Your response must be concise. 0.87. What is the ratio of the Production index(2004-2006) of Lao PDR in 1974 to that in 1977?
Offer a terse response. 1.16. What is the ratio of the Production index(2004-2006) of Nepal in 1974 to that in 1977?
Your answer should be very brief. 0.98. What is the ratio of the Production index(2004-2006) of Costa Rica in 1974 to that in 1978?
Offer a very short reply. 0.84. What is the ratio of the Production index(2004-2006) of Estonia in 1974 to that in 1978?
Offer a very short reply. 0.84. What is the ratio of the Production index(2004-2006) of Lao PDR in 1974 to that in 1978?
Give a very brief answer. 1.12. What is the ratio of the Production index(2004-2006) of Nepal in 1974 to that in 1978?
Your answer should be very brief. 0.95. What is the ratio of the Production index(2004-2006) of Costa Rica in 1974 to that in 1979?
Offer a terse response. 0.82. What is the ratio of the Production index(2004-2006) of Estonia in 1974 to that in 1979?
Provide a short and direct response. 0.83. What is the ratio of the Production index(2004-2006) in Lao PDR in 1974 to that in 1979?
Your answer should be compact. 0.95. What is the ratio of the Production index(2004-2006) in Nepal in 1974 to that in 1979?
Your answer should be very brief. 0.98. What is the ratio of the Production index(2004-2006) of Costa Rica in 1974 to that in 1980?
Provide a short and direct response. 0.84. What is the ratio of the Production index(2004-2006) in Estonia in 1974 to that in 1980?
Provide a succinct answer. 0.8. What is the ratio of the Production index(2004-2006) of Lao PDR in 1974 to that in 1980?
Provide a short and direct response. 0.8. What is the ratio of the Production index(2004-2006) in Nepal in 1974 to that in 1980?
Ensure brevity in your answer.  0.9. What is the ratio of the Production index(2004-2006) in Costa Rica in 1974 to that in 1992?
Keep it short and to the point. 0.49. What is the ratio of the Production index(2004-2006) of Estonia in 1974 to that in 1992?
Offer a terse response. 0.64. What is the ratio of the Production index(2004-2006) of Lao PDR in 1974 to that in 1992?
Make the answer very short. 0.53. What is the ratio of the Production index(2004-2006) in Nepal in 1974 to that in 1992?
Offer a very short reply. 0.56. What is the ratio of the Production index(2004-2006) of Costa Rica in 1975 to that in 1976?
Keep it short and to the point. 0.97. What is the ratio of the Production index(2004-2006) of Estonia in 1975 to that in 1976?
Keep it short and to the point. 1.03. What is the ratio of the Production index(2004-2006) in Lao PDR in 1975 to that in 1976?
Make the answer very short. 1.19. What is the ratio of the Production index(2004-2006) in Nepal in 1975 to that in 1976?
Keep it short and to the point. 1.02. What is the ratio of the Production index(2004-2006) of Costa Rica in 1975 to that in 1977?
Provide a succinct answer. 0.95. What is the ratio of the Production index(2004-2006) of Estonia in 1975 to that in 1977?
Ensure brevity in your answer.  0.98. What is the ratio of the Production index(2004-2006) in Lao PDR in 1975 to that in 1977?
Provide a short and direct response. 1.14. What is the ratio of the Production index(2004-2006) of Costa Rica in 1975 to that in 1978?
Your answer should be very brief. 0.95. What is the ratio of the Production index(2004-2006) of Estonia in 1975 to that in 1978?
Your answer should be very brief. 0.95. What is the ratio of the Production index(2004-2006) in Lao PDR in 1975 to that in 1978?
Your response must be concise. 1.1. What is the ratio of the Production index(2004-2006) of Nepal in 1975 to that in 1978?
Offer a very short reply. 1. What is the ratio of the Production index(2004-2006) in Costa Rica in 1975 to that in 1979?
Offer a very short reply. 0.92. What is the ratio of the Production index(2004-2006) of Estonia in 1975 to that in 1979?
Provide a succinct answer. 0.94. What is the ratio of the Production index(2004-2006) of Lao PDR in 1975 to that in 1979?
Your answer should be compact. 0.93. What is the ratio of the Production index(2004-2006) of Nepal in 1975 to that in 1979?
Your response must be concise. 1.03. What is the ratio of the Production index(2004-2006) in Costa Rica in 1975 to that in 1980?
Your response must be concise. 0.95. What is the ratio of the Production index(2004-2006) in Estonia in 1975 to that in 1980?
Offer a terse response. 0.9. What is the ratio of the Production index(2004-2006) in Lao PDR in 1975 to that in 1980?
Your answer should be compact. 0.78. What is the ratio of the Production index(2004-2006) in Nepal in 1975 to that in 1980?
Your response must be concise. 0.94. What is the ratio of the Production index(2004-2006) of Costa Rica in 1975 to that in 1992?
Offer a very short reply. 0.56. What is the ratio of the Production index(2004-2006) in Estonia in 1975 to that in 1992?
Your response must be concise. 0.72. What is the ratio of the Production index(2004-2006) in Lao PDR in 1975 to that in 1992?
Provide a short and direct response. 0.52. What is the ratio of the Production index(2004-2006) in Nepal in 1975 to that in 1992?
Provide a short and direct response. 0.59. What is the ratio of the Production index(2004-2006) in Costa Rica in 1976 to that in 1977?
Your answer should be compact. 0.98. What is the ratio of the Production index(2004-2006) of Estonia in 1976 to that in 1977?
Provide a succinct answer. 0.95. What is the ratio of the Production index(2004-2006) in Lao PDR in 1976 to that in 1977?
Provide a succinct answer. 0.96. What is the ratio of the Production index(2004-2006) in Nepal in 1976 to that in 1977?
Keep it short and to the point. 1.01. What is the ratio of the Production index(2004-2006) of Costa Rica in 1976 to that in 1978?
Ensure brevity in your answer.  0.98. What is the ratio of the Production index(2004-2006) in Estonia in 1976 to that in 1978?
Your answer should be compact. 0.92. What is the ratio of the Production index(2004-2006) of Lao PDR in 1976 to that in 1978?
Your response must be concise. 0.92. What is the ratio of the Production index(2004-2006) of Nepal in 1976 to that in 1978?
Keep it short and to the point. 0.98. What is the ratio of the Production index(2004-2006) in Costa Rica in 1976 to that in 1979?
Offer a very short reply. 0.95. What is the ratio of the Production index(2004-2006) of Estonia in 1976 to that in 1979?
Your response must be concise. 0.91. What is the ratio of the Production index(2004-2006) of Lao PDR in 1976 to that in 1979?
Your response must be concise. 0.79. What is the ratio of the Production index(2004-2006) in Nepal in 1976 to that in 1979?
Ensure brevity in your answer.  1.01. What is the ratio of the Production index(2004-2006) in Costa Rica in 1976 to that in 1980?
Your answer should be compact. 0.98. What is the ratio of the Production index(2004-2006) in Estonia in 1976 to that in 1980?
Offer a very short reply. 0.87. What is the ratio of the Production index(2004-2006) in Lao PDR in 1976 to that in 1980?
Ensure brevity in your answer.  0.66. What is the ratio of the Production index(2004-2006) of Nepal in 1976 to that in 1980?
Offer a terse response. 0.92. What is the ratio of the Production index(2004-2006) of Costa Rica in 1976 to that in 1992?
Your answer should be compact. 0.58. What is the ratio of the Production index(2004-2006) in Estonia in 1976 to that in 1992?
Provide a short and direct response. 0.7. What is the ratio of the Production index(2004-2006) of Lao PDR in 1976 to that in 1992?
Provide a succinct answer. 0.43. What is the ratio of the Production index(2004-2006) of Nepal in 1976 to that in 1992?
Provide a succinct answer. 0.58. What is the ratio of the Production index(2004-2006) of Costa Rica in 1977 to that in 1978?
Offer a very short reply. 1. What is the ratio of the Production index(2004-2006) in Estonia in 1977 to that in 1978?
Provide a short and direct response. 0.96. What is the ratio of the Production index(2004-2006) of Lao PDR in 1977 to that in 1978?
Your response must be concise. 0.96. What is the ratio of the Production index(2004-2006) in Nepal in 1977 to that in 1978?
Offer a terse response. 0.97. What is the ratio of the Production index(2004-2006) of Costa Rica in 1977 to that in 1979?
Your answer should be very brief. 0.97. What is the ratio of the Production index(2004-2006) of Estonia in 1977 to that in 1979?
Ensure brevity in your answer.  0.95. What is the ratio of the Production index(2004-2006) in Lao PDR in 1977 to that in 1979?
Give a very brief answer. 0.82. What is the ratio of the Production index(2004-2006) in Nepal in 1977 to that in 1979?
Your answer should be very brief. 1. What is the ratio of the Production index(2004-2006) of Costa Rica in 1977 to that in 1980?
Give a very brief answer. 1. What is the ratio of the Production index(2004-2006) in Estonia in 1977 to that in 1980?
Provide a short and direct response. 0.91. What is the ratio of the Production index(2004-2006) of Lao PDR in 1977 to that in 1980?
Make the answer very short. 0.69. What is the ratio of the Production index(2004-2006) in Nepal in 1977 to that in 1980?
Keep it short and to the point. 0.92. What is the ratio of the Production index(2004-2006) of Costa Rica in 1977 to that in 1992?
Ensure brevity in your answer.  0.58. What is the ratio of the Production index(2004-2006) of Estonia in 1977 to that in 1992?
Give a very brief answer. 0.74. What is the ratio of the Production index(2004-2006) of Lao PDR in 1977 to that in 1992?
Offer a terse response. 0.45. What is the ratio of the Production index(2004-2006) of Nepal in 1977 to that in 1992?
Provide a succinct answer. 0.57. What is the ratio of the Production index(2004-2006) of Costa Rica in 1978 to that in 1979?
Your answer should be very brief. 0.97. What is the ratio of the Production index(2004-2006) in Lao PDR in 1978 to that in 1979?
Give a very brief answer. 0.85. What is the ratio of the Production index(2004-2006) of Nepal in 1978 to that in 1979?
Provide a succinct answer. 1.04. What is the ratio of the Production index(2004-2006) of Estonia in 1978 to that in 1980?
Provide a short and direct response. 0.95. What is the ratio of the Production index(2004-2006) in Lao PDR in 1978 to that in 1980?
Provide a short and direct response. 0.72. What is the ratio of the Production index(2004-2006) of Nepal in 1978 to that in 1980?
Offer a very short reply. 0.94. What is the ratio of the Production index(2004-2006) in Costa Rica in 1978 to that in 1992?
Give a very brief answer. 0.58. What is the ratio of the Production index(2004-2006) in Estonia in 1978 to that in 1992?
Keep it short and to the point. 0.77. What is the ratio of the Production index(2004-2006) of Lao PDR in 1978 to that in 1992?
Give a very brief answer. 0.47. What is the ratio of the Production index(2004-2006) of Nepal in 1978 to that in 1992?
Your answer should be very brief. 0.59. What is the ratio of the Production index(2004-2006) of Costa Rica in 1979 to that in 1980?
Provide a succinct answer. 1.03. What is the ratio of the Production index(2004-2006) of Estonia in 1979 to that in 1980?
Make the answer very short. 0.95. What is the ratio of the Production index(2004-2006) in Lao PDR in 1979 to that in 1980?
Offer a terse response. 0.84. What is the ratio of the Production index(2004-2006) of Nepal in 1979 to that in 1980?
Make the answer very short. 0.91. What is the ratio of the Production index(2004-2006) in Costa Rica in 1979 to that in 1992?
Your answer should be very brief. 0.6. What is the ratio of the Production index(2004-2006) in Estonia in 1979 to that in 1992?
Provide a short and direct response. 0.77. What is the ratio of the Production index(2004-2006) in Lao PDR in 1979 to that in 1992?
Your response must be concise. 0.55. What is the ratio of the Production index(2004-2006) in Nepal in 1979 to that in 1992?
Provide a short and direct response. 0.57. What is the ratio of the Production index(2004-2006) in Costa Rica in 1980 to that in 1992?
Your answer should be compact. 0.59. What is the ratio of the Production index(2004-2006) of Estonia in 1980 to that in 1992?
Keep it short and to the point. 0.81. What is the ratio of the Production index(2004-2006) of Lao PDR in 1980 to that in 1992?
Provide a short and direct response. 0.66. What is the ratio of the Production index(2004-2006) of Nepal in 1980 to that in 1992?
Make the answer very short. 0.62. What is the difference between the highest and the second highest Production index(2004-2006) of Costa Rica?
Your answer should be very brief. 26.1. What is the difference between the highest and the second highest Production index(2004-2006) of Estonia?
Your answer should be very brief. 27.82. What is the difference between the highest and the second highest Production index(2004-2006) of Lao PDR?
Your answer should be compact. 17.37. What is the difference between the highest and the second highest Production index(2004-2006) of Nepal?
Make the answer very short. 24.59. What is the difference between the highest and the lowest Production index(2004-2006) in Costa Rica?
Give a very brief answer. 33.36. What is the difference between the highest and the lowest Production index(2004-2006) of Estonia?
Provide a succinct answer. 51.75. What is the difference between the highest and the lowest Production index(2004-2006) in Lao PDR?
Your answer should be very brief. 28.65. What is the difference between the highest and the lowest Production index(2004-2006) in Nepal?
Provide a short and direct response. 28.7. 